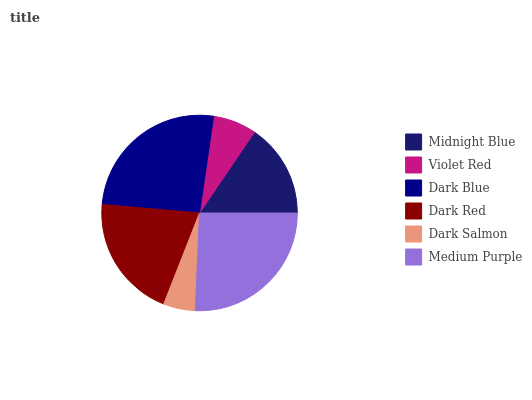Is Dark Salmon the minimum?
Answer yes or no. Yes. Is Dark Blue the maximum?
Answer yes or no. Yes. Is Violet Red the minimum?
Answer yes or no. No. Is Violet Red the maximum?
Answer yes or no. No. Is Midnight Blue greater than Violet Red?
Answer yes or no. Yes. Is Violet Red less than Midnight Blue?
Answer yes or no. Yes. Is Violet Red greater than Midnight Blue?
Answer yes or no. No. Is Midnight Blue less than Violet Red?
Answer yes or no. No. Is Dark Red the high median?
Answer yes or no. Yes. Is Midnight Blue the low median?
Answer yes or no. Yes. Is Midnight Blue the high median?
Answer yes or no. No. Is Medium Purple the low median?
Answer yes or no. No. 